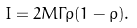Convert formula to latex. <formula><loc_0><loc_0><loc_500><loc_500>I = 2 M \Gamma \rho ( 1 - \rho ) .</formula> 